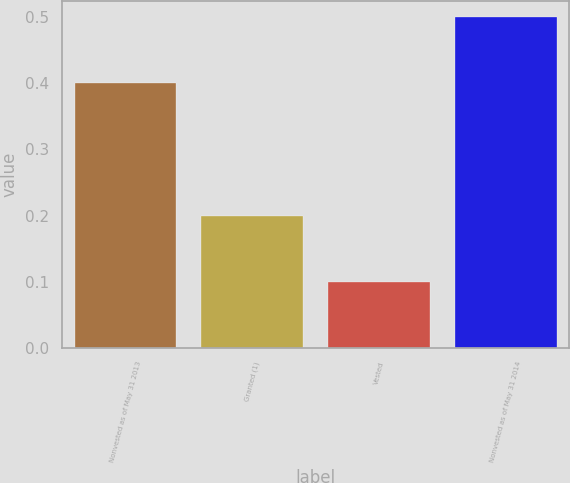Convert chart. <chart><loc_0><loc_0><loc_500><loc_500><bar_chart><fcel>Nonvested as of May 31 2013<fcel>Granted (1)<fcel>Vested<fcel>Nonvested as of May 31 2014<nl><fcel>0.4<fcel>0.2<fcel>0.1<fcel>0.5<nl></chart> 